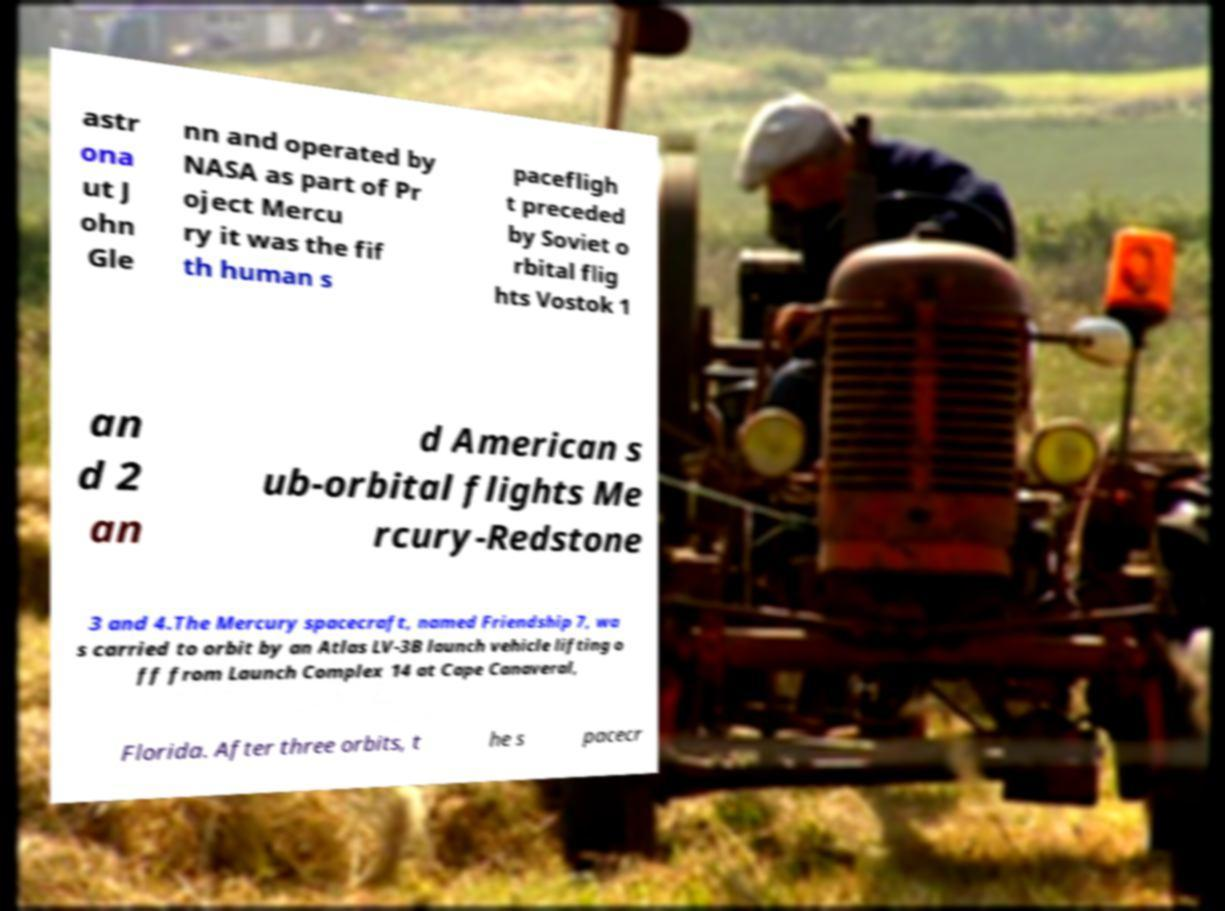Could you assist in decoding the text presented in this image and type it out clearly? astr ona ut J ohn Gle nn and operated by NASA as part of Pr oject Mercu ry it was the fif th human s pacefligh t preceded by Soviet o rbital flig hts Vostok 1 an d 2 an d American s ub-orbital flights Me rcury-Redstone 3 and 4.The Mercury spacecraft, named Friendship 7, wa s carried to orbit by an Atlas LV-3B launch vehicle lifting o ff from Launch Complex 14 at Cape Canaveral, Florida. After three orbits, t he s pacecr 